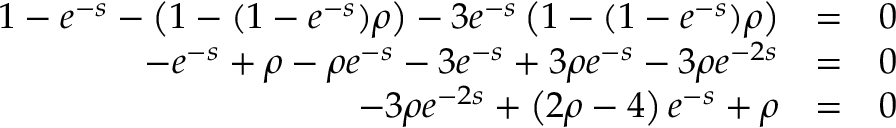Convert formula to latex. <formula><loc_0><loc_0><loc_500><loc_500>\begin{array} { r l r } { 1 - e ^ { - s } - \left ( 1 - ( 1 - e ^ { - s } ) \rho \right ) - 3 e ^ { - s } \left ( 1 - ( 1 - e ^ { - s } ) \rho \right ) } & { = } & { 0 } \\ { - e ^ { - s } + \rho - \rho e ^ { - s } - 3 e ^ { - s } + 3 \rho e ^ { - s } - 3 \rho e ^ { - 2 s } } & { = } & { 0 } \\ { - 3 \rho e ^ { - 2 s } + \left ( 2 \rho - 4 \right ) e ^ { - s } + \rho } & { = } & { 0 } \end{array}</formula> 